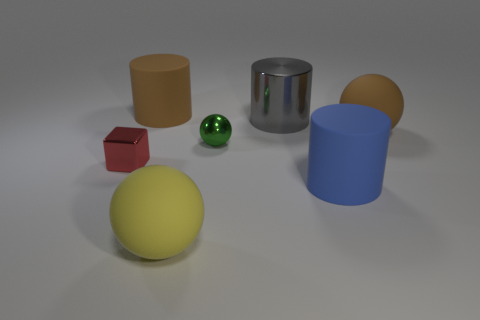Subtract 1 cubes. How many cubes are left? 0 Add 2 big gray objects. How many objects exist? 9 Subtract all big rubber balls. How many balls are left? 1 Subtract all blocks. How many objects are left? 6 Add 6 small yellow shiny cubes. How many small yellow shiny cubes exist? 6 Subtract 1 brown spheres. How many objects are left? 6 Subtract all green cubes. Subtract all red cylinders. How many cubes are left? 1 Subtract all brown cylinders. How many blue cubes are left? 0 Subtract all cyan rubber blocks. Subtract all big yellow objects. How many objects are left? 6 Add 6 small balls. How many small balls are left? 7 